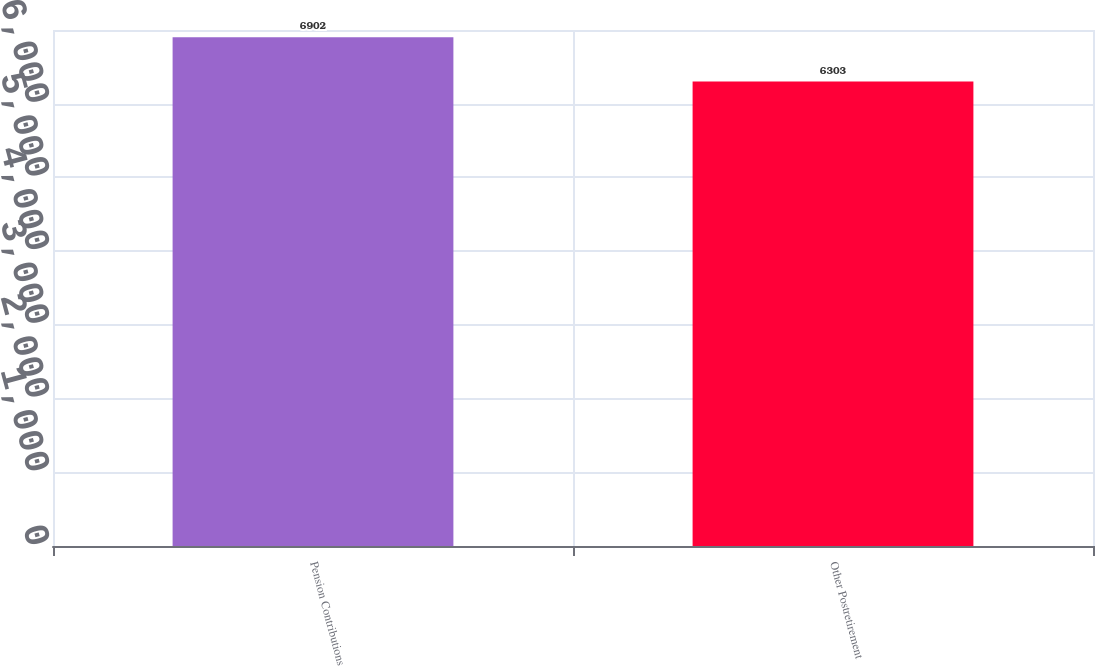Convert chart to OTSL. <chart><loc_0><loc_0><loc_500><loc_500><bar_chart><fcel>Pension Contributions<fcel>Other Postretirement<nl><fcel>6902<fcel>6303<nl></chart> 